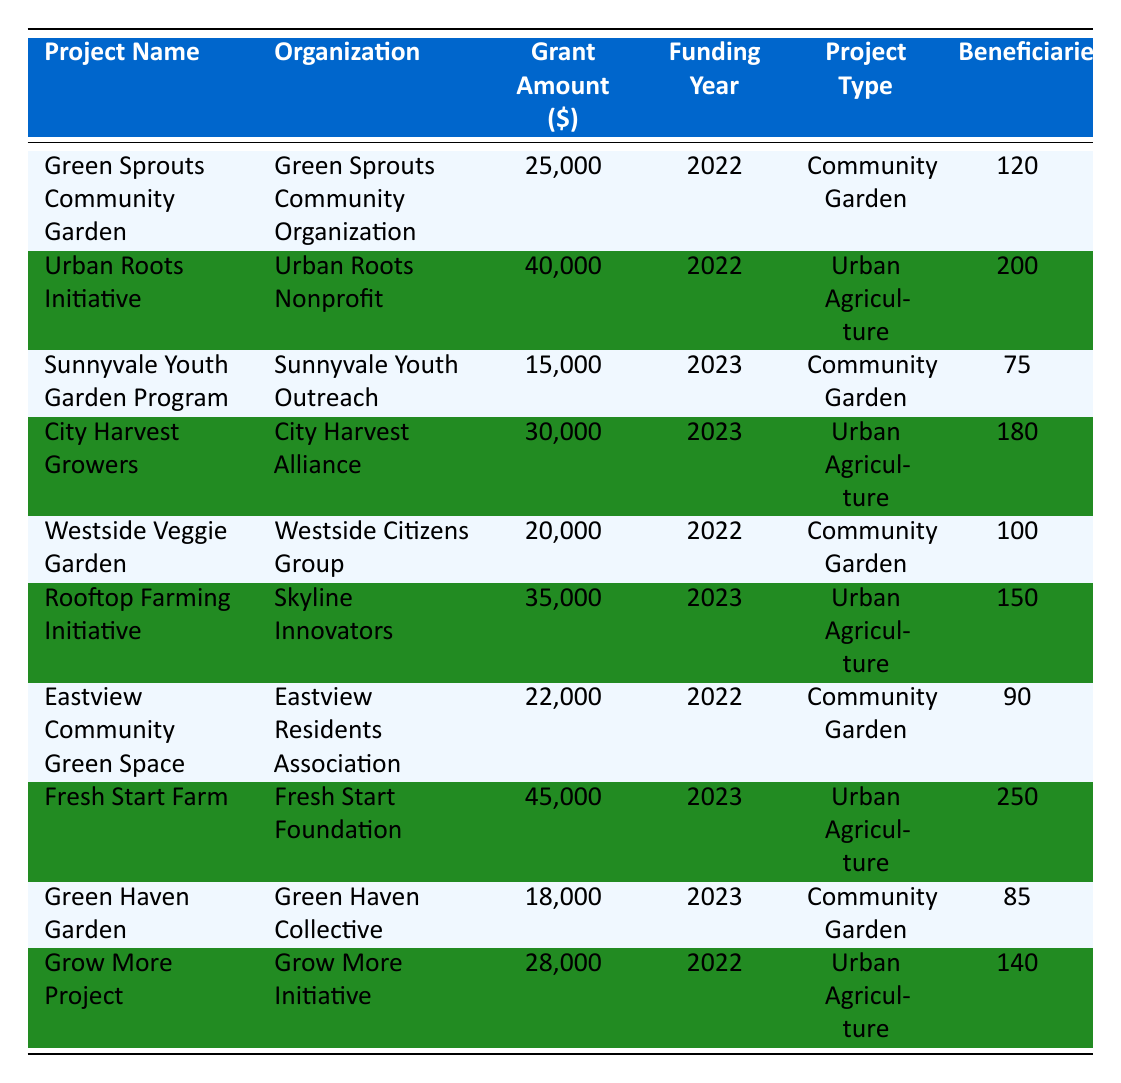What is the grant amount for the Fresh Start Farm project? From the table, the Fresh Start Farm project has a listed Grant Amount of 45000 dollars.
Answer: 45000 Which project has the highest number of beneficiaries? By reviewing the Number of Beneficiaries column, the Fresh Start Farm project has the highest number with 250 beneficiaries.
Answer: 250 What is the total grant amount distributed to Community Gardens in 2022? The total grant amount for Community Gardens in 2022 includes Green Sprouts Community Garden (25000), Westside Veggie Garden (20000), and Eastview Community Green Space (22000). Summing these amounts gives 25000 + 20000 + 22000 = 67000.
Answer: 67000 Is there any Urban Agriculture project that received more than 30000 dollars in funding? Looking at the Urban Agriculture projects, Urban Roots Initiative received 40000 dollars, and Fresh Start Farm received 45000 dollars. Therefore, the answer is yes.
Answer: Yes What is the average grant amount for Community Gardens across all years listed? The grant amounts for Community Gardens are 25000 (Green Sprouts), 15000 (Sunnyvale Youth), 20000 (Westside Veggie), 22000 (Eastview), and 18000 (Green Haven). Adding these results in a total of 25000 + 15000 + 20000 + 22000 + 18000 = 100000. Dividing by the number of projects (5) gives an average of 100000 / 5 = 20000.
Answer: 20000 Which organization received funding for the Rooftop Farming Initiative? The Rooftop Farming Initiative is funded by the Skyline Innovators, as indicated in the Organization column.
Answer: Skyline Innovators How many total beneficiaries are served by Urban Agriculture projects? The Number of Beneficiaries for Urban Agriculture projects are 200 (Urban Roots Initiative), 180 (City Harvest Growers), 150 (Rooftop Farming Initiative), and 250 (Fresh Start Farm). Summing these gives 200 + 180 + 150 + 250 = 780 total beneficiaries.
Answer: 780 Is it true that all Community Garden projects received less than 30000 dollars in funding? Reviewing the funding amounts, Green Sprouts (25000), Sunnyvale Youth (15000), Westside Veggie (20000), Eastview (22000), and Green Haven (18000) all received less than 30000 dollars, so the statement is true.
Answer: True 